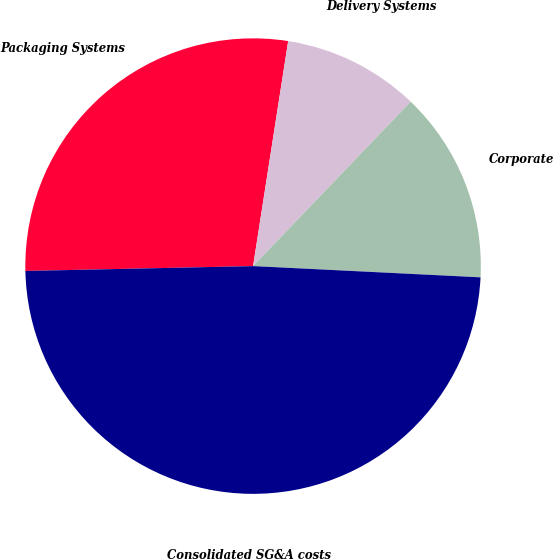<chart> <loc_0><loc_0><loc_500><loc_500><pie_chart><fcel>Packaging Systems<fcel>Delivery Systems<fcel>Corporate<fcel>Consolidated SG&A costs<nl><fcel>27.8%<fcel>9.7%<fcel>13.62%<fcel>48.87%<nl></chart> 